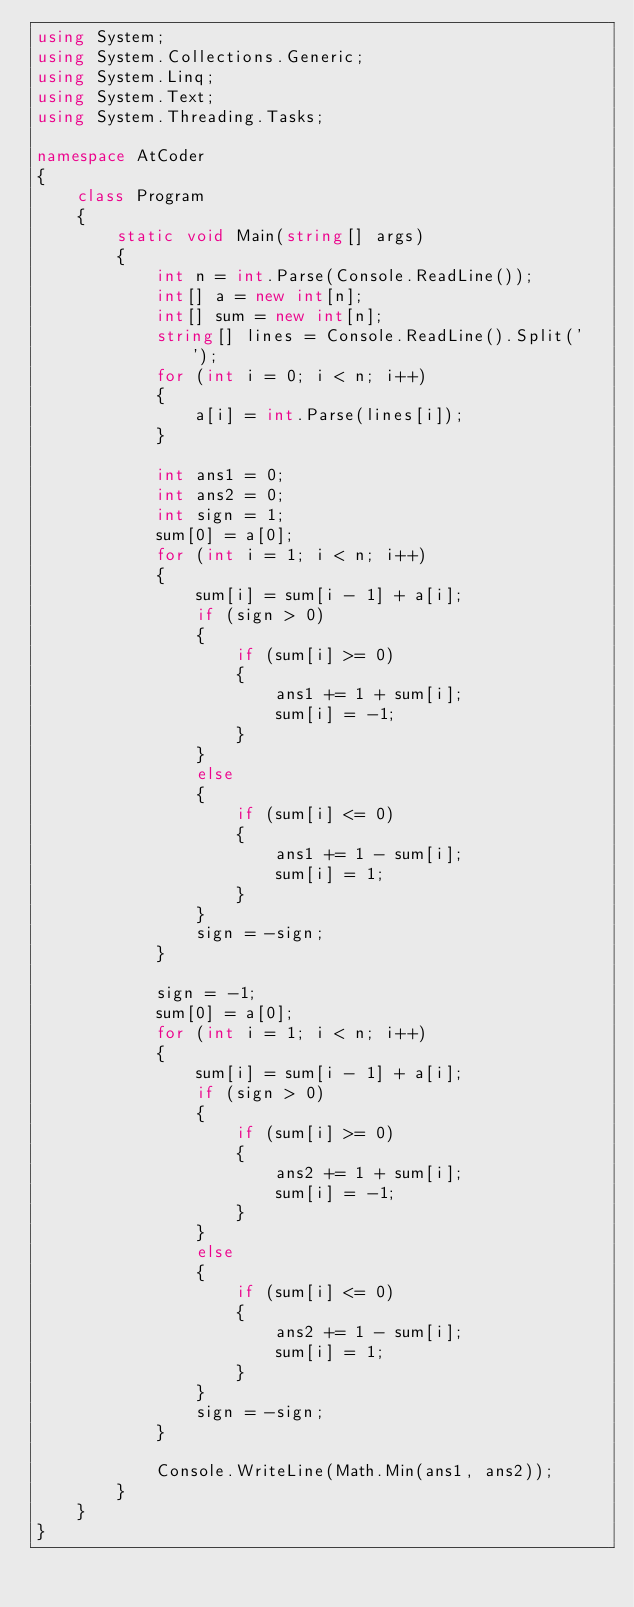Convert code to text. <code><loc_0><loc_0><loc_500><loc_500><_C#_>using System;
using System.Collections.Generic;
using System.Linq;
using System.Text;
using System.Threading.Tasks;

namespace AtCoder
{
    class Program
    {
        static void Main(string[] args)
        {
            int n = int.Parse(Console.ReadLine());
            int[] a = new int[n];
            int[] sum = new int[n];
            string[] lines = Console.ReadLine().Split(' ');
            for (int i = 0; i < n; i++)
            {
                a[i] = int.Parse(lines[i]);
            }

            int ans1 = 0;
            int ans2 = 0;
            int sign = 1;
            sum[0] = a[0];
            for (int i = 1; i < n; i++)
            {
                sum[i] = sum[i - 1] + a[i];
                if (sign > 0)
                {
                    if (sum[i] >= 0)
                    {
                        ans1 += 1 + sum[i];
                        sum[i] = -1;
                    }
                }
                else
                {
                    if (sum[i] <= 0)
                    {
                        ans1 += 1 - sum[i];
                        sum[i] = 1;
                    }
                }
                sign = -sign;
            }

            sign = -1;
            sum[0] = a[0];
            for (int i = 1; i < n; i++)
            {
                sum[i] = sum[i - 1] + a[i];
                if (sign > 0)
                {
                    if (sum[i] >= 0)
                    {
                        ans2 += 1 + sum[i];
                        sum[i] = -1;
                    }
                }
                else
                {
                    if (sum[i] <= 0)
                    {
                        ans2 += 1 - sum[i];
                        sum[i] = 1;
                    }
                }
                sign = -sign;
            }

            Console.WriteLine(Math.Min(ans1, ans2));
        }
    }
}
</code> 